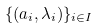<formula> <loc_0><loc_0><loc_500><loc_500>\{ ( a _ { i } , \lambda _ { i } ) \} _ { i \in I }</formula> 